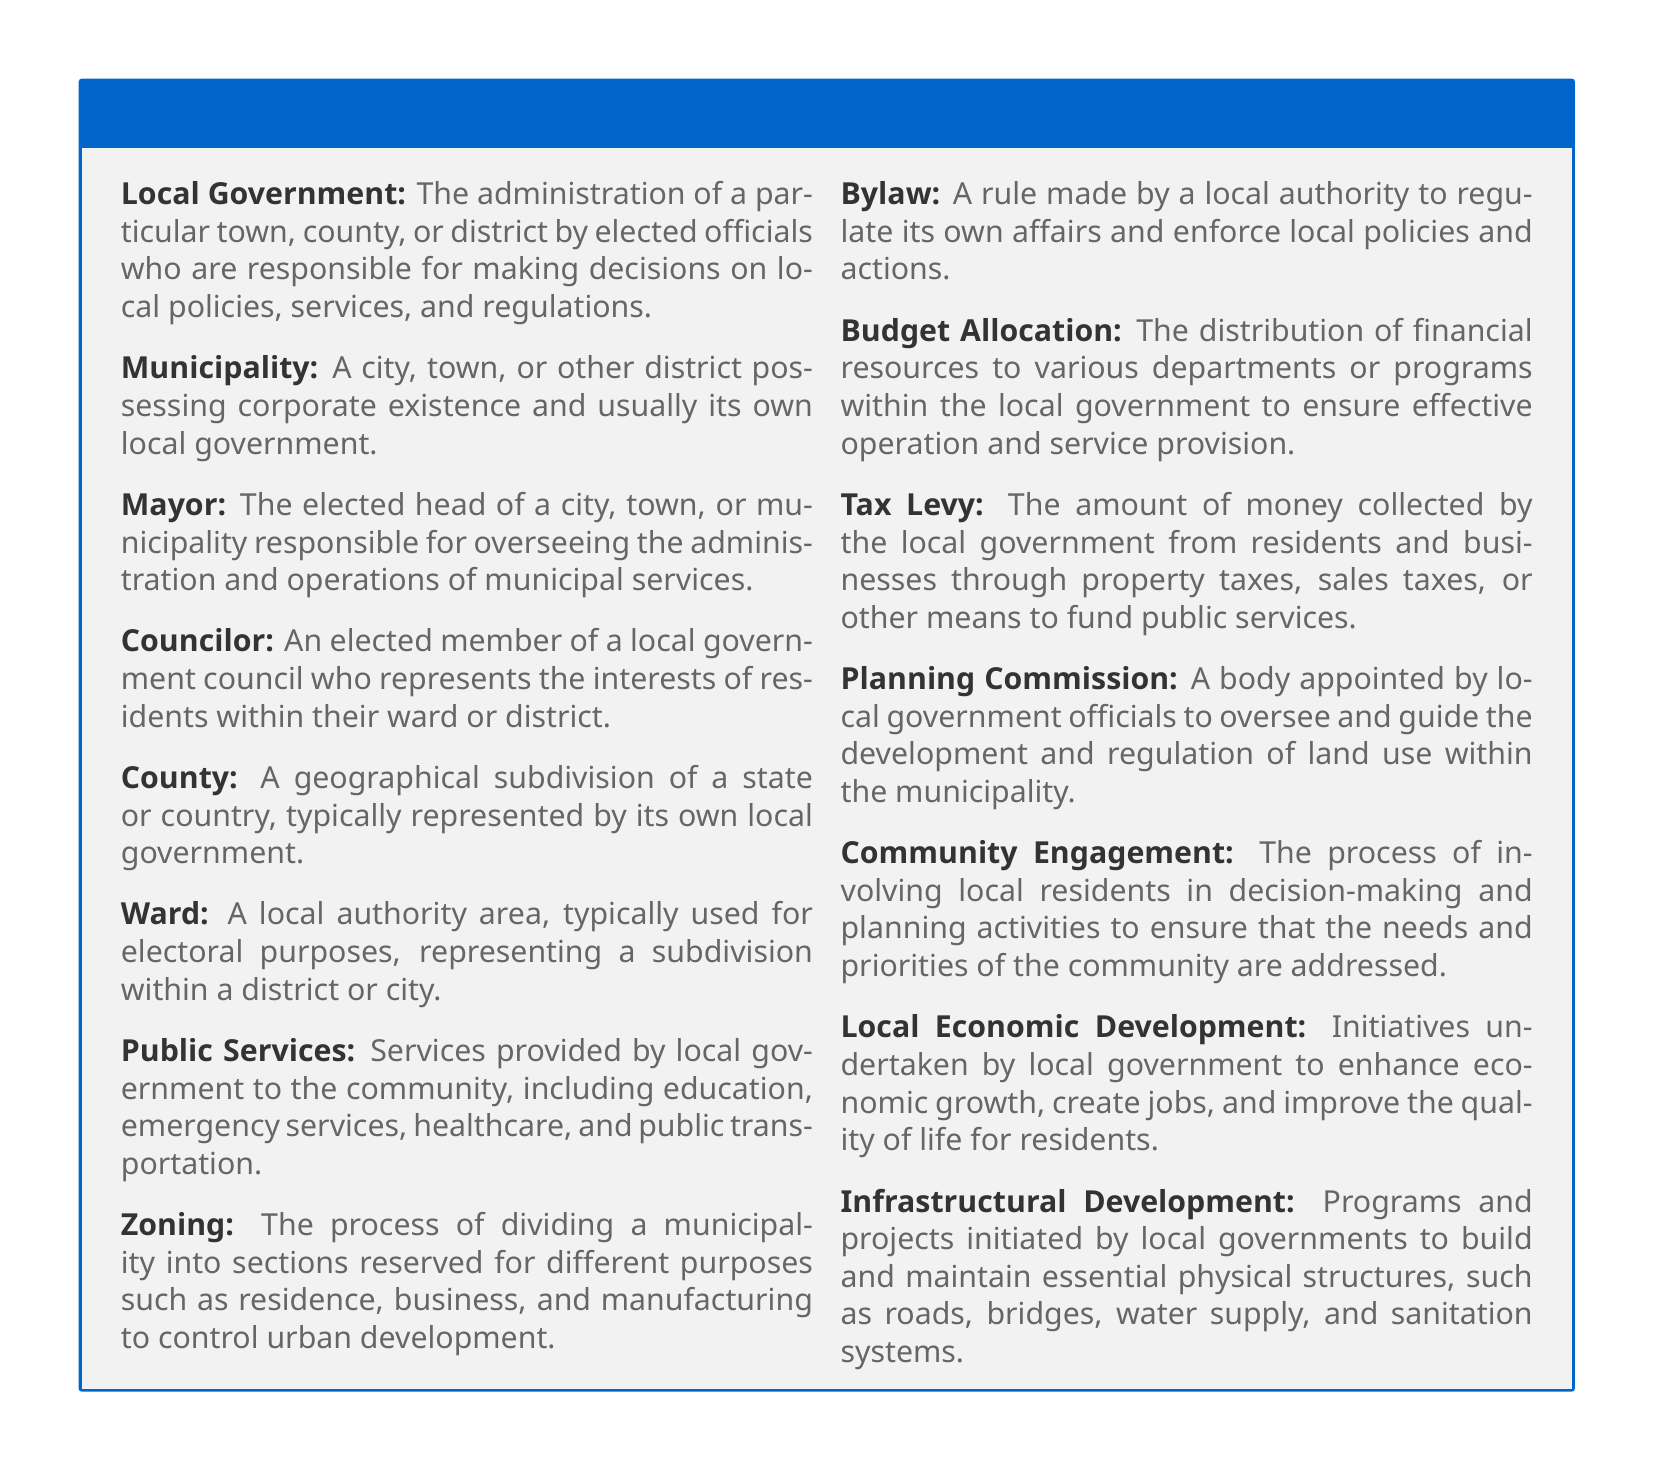What is the definition of Local Government? Local Government is defined in the document as the administration of a particular town, county, or district by elected officials who are responsible for making decisions on local policies, services, and regulations.
Answer: The administration of a particular town, county, or district by elected officials Who is responsible for overseeing municipal services? The document states that the Mayor is the elected head responsible for overseeing the administration and operations of municipal services.
Answer: The Mayor What is a Ward? A Ward is defined in the document as a local authority area, typically used for electoral purposes, representing a subdivision within a district or city.
Answer: A local authority area used for electoral purposes What is the purpose of a Zoning process? The Zoning definition indicates it is the process of dividing a municipality into sections reserved for different purposes to control urban development.
Answer: To control urban development What does Public Services encompass? The document lists that Public Services include community resources such as education, emergency services, healthcare, and public transportation.
Answer: Education, emergency services, healthcare, and public transportation What is Budget Allocation? Budget Allocation in the document refers to the distribution of financial resources to various departments or programs within the local government.
Answer: Distribution of financial resources to departments What is the role of a Planning Commission? The document explains that the Planning Commission is a body appointed to oversee and guide the development and regulation of land use within the municipality.
Answer: To oversee and guide the development and regulation of land use What does Community Engagement involve? According to the document, Community Engagement involves local residents in decision-making and planning activities to ensure their needs are met.
Answer: Involving local residents in decision-making How does Local Economic Development improve quality of life? The document states that Local Economic Development initiatives enhance economic growth, create jobs, and improve the quality of life for residents.
Answer: Enhance economic growth and create jobs 